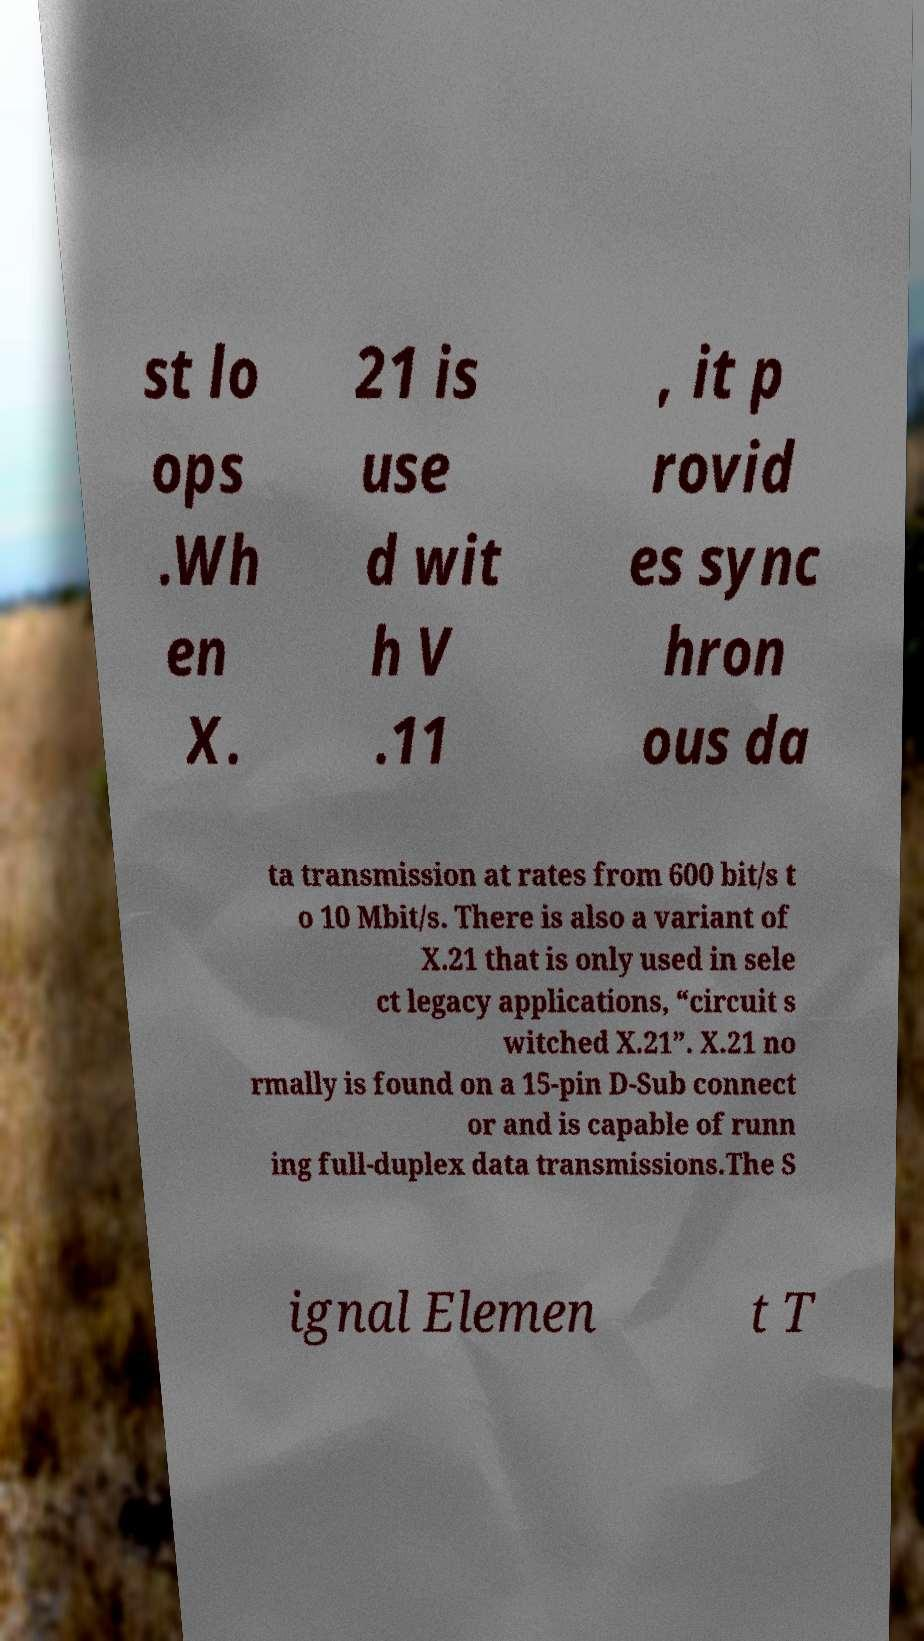There's text embedded in this image that I need extracted. Can you transcribe it verbatim? st lo ops .Wh en X. 21 is use d wit h V .11 , it p rovid es sync hron ous da ta transmission at rates from 600 bit/s t o 10 Mbit/s. There is also a variant of X.21 that is only used in sele ct legacy applications, “circuit s witched X.21”. X.21 no rmally is found on a 15-pin D-Sub connect or and is capable of runn ing full-duplex data transmissions.The S ignal Elemen t T 